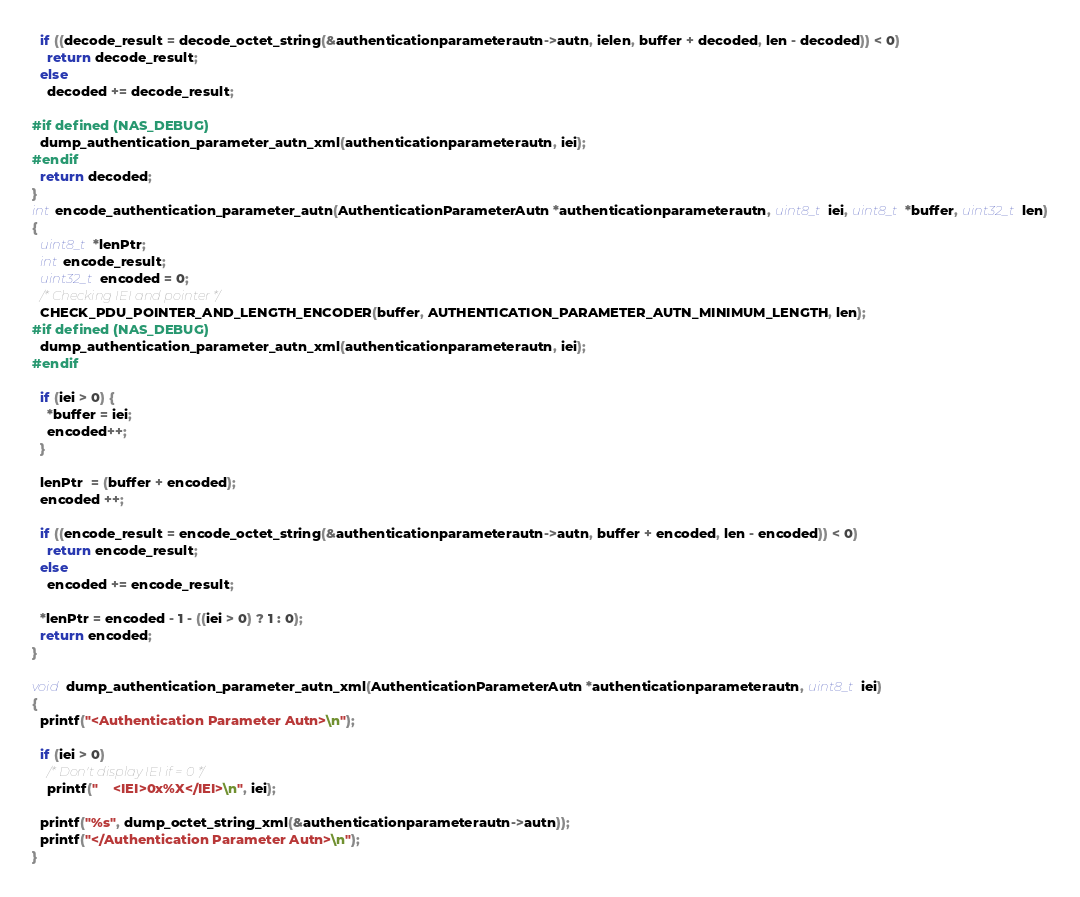Convert code to text. <code><loc_0><loc_0><loc_500><loc_500><_C_>  if ((decode_result = decode_octet_string(&authenticationparameterautn->autn, ielen, buffer + decoded, len - decoded)) < 0)
    return decode_result;
  else
    decoded += decode_result;

#if defined (NAS_DEBUG)
  dump_authentication_parameter_autn_xml(authenticationparameterautn, iei);
#endif
  return decoded;
}
int encode_authentication_parameter_autn(AuthenticationParameterAutn *authenticationparameterautn, uint8_t iei, uint8_t *buffer, uint32_t len)
{
  uint8_t *lenPtr;
  int encode_result;
  uint32_t encoded = 0;
  /* Checking IEI and pointer */
  CHECK_PDU_POINTER_AND_LENGTH_ENCODER(buffer, AUTHENTICATION_PARAMETER_AUTN_MINIMUM_LENGTH, len);
#if defined (NAS_DEBUG)
  dump_authentication_parameter_autn_xml(authenticationparameterautn, iei);
#endif

  if (iei > 0) {
    *buffer = iei;
    encoded++;
  }

  lenPtr  = (buffer + encoded);
  encoded ++;

  if ((encode_result = encode_octet_string(&authenticationparameterautn->autn, buffer + encoded, len - encoded)) < 0)
    return encode_result;
  else
    encoded += encode_result;

  *lenPtr = encoded - 1 - ((iei > 0) ? 1 : 0);
  return encoded;
}

void dump_authentication_parameter_autn_xml(AuthenticationParameterAutn *authenticationparameterautn, uint8_t iei)
{
  printf("<Authentication Parameter Autn>\n");

  if (iei > 0)
    /* Don't display IEI if = 0 */
    printf("    <IEI>0x%X</IEI>\n", iei);

  printf("%s", dump_octet_string_xml(&authenticationparameterautn->autn));
  printf("</Authentication Parameter Autn>\n");
}

</code> 